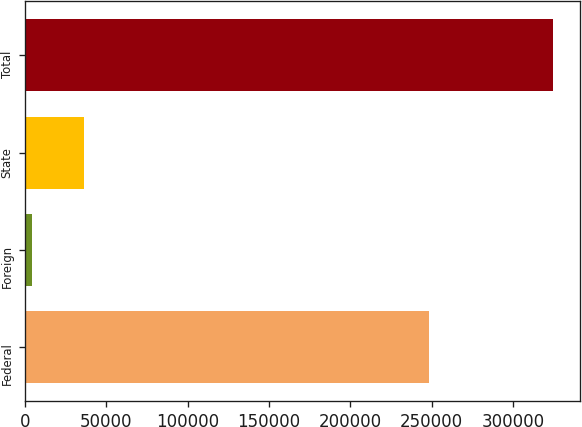<chart> <loc_0><loc_0><loc_500><loc_500><bar_chart><fcel>Federal<fcel>Foreign<fcel>State<fcel>Total<nl><fcel>248172<fcel>4167<fcel>36217.4<fcel>324671<nl></chart> 